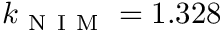<formula> <loc_0><loc_0><loc_500><loc_500>k _ { N I M } = 1 . 3 2 8</formula> 